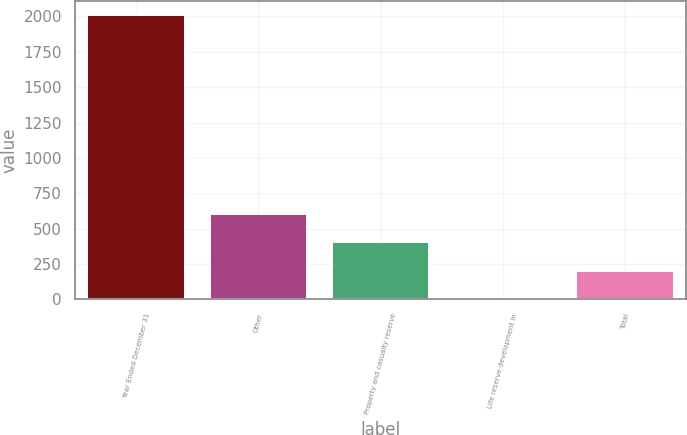Convert chart to OTSL. <chart><loc_0><loc_0><loc_500><loc_500><bar_chart><fcel>Year Ended December 31<fcel>Other<fcel>Property and casualty reserve<fcel>Life reserve development in<fcel>Total<nl><fcel>2008<fcel>603.8<fcel>403.2<fcel>2<fcel>202.6<nl></chart> 